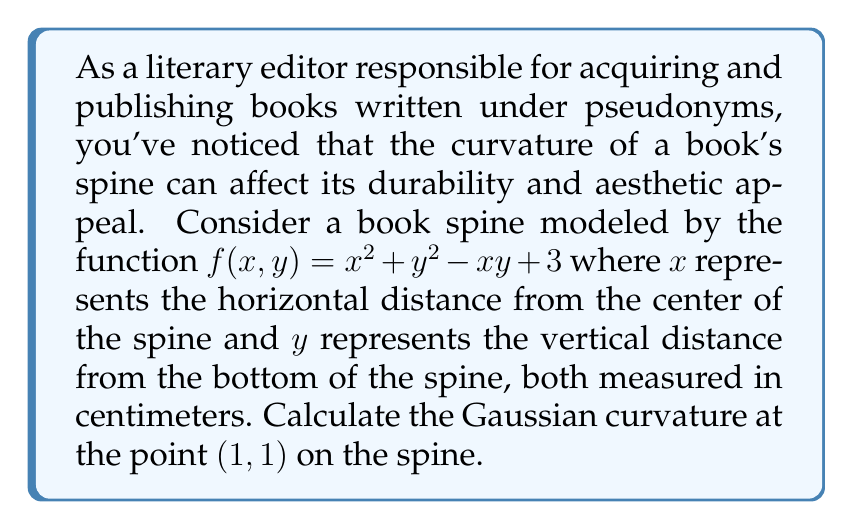Can you answer this question? To find the Gaussian curvature of the book spine at the point $(1,1)$, we need to follow these steps:

1) The Gaussian curvature $K$ is given by the formula:

   $$K = \frac{f_{xx}f_{yy} - f_{xy}^2}{(1 + f_x^2 + f_y^2)^2}$$

   where $f_x$, $f_y$ are first partial derivatives, and $f_{xx}$, $f_{yy}$, $f_{xy}$ are second partial derivatives.

2) Let's calculate the first partial derivatives:
   
   $f_x = 2x - y$
   $f_y = 2y - x$

3) Now, let's calculate the second partial derivatives:
   
   $f_{xx} = 2$
   $f_{yy} = 2$
   $f_{xy} = -1$

4) Evaluate these at the point $(1,1)$:
   
   $f_x(1,1) = 2(1) - 1 = 1$
   $f_y(1,1) = 2(1) - 1 = 1$
   $f_{xx}(1,1) = 2$
   $f_{yy}(1,1) = 2$
   $f_{xy}(1,1) = -1$

5) Now we can substitute these values into the Gaussian curvature formula:

   $$K = \frac{(2)(2) - (-1)^2}{(1 + 1^2 + 1^2)^2} = \frac{4 - 1}{(1 + 1 + 1)^2} = \frac{3}{9} = \frac{1}{3}$$

Thus, the Gaussian curvature at the point $(1,1)$ is $\frac{1}{3}$.
Answer: $\frac{1}{3}$ 